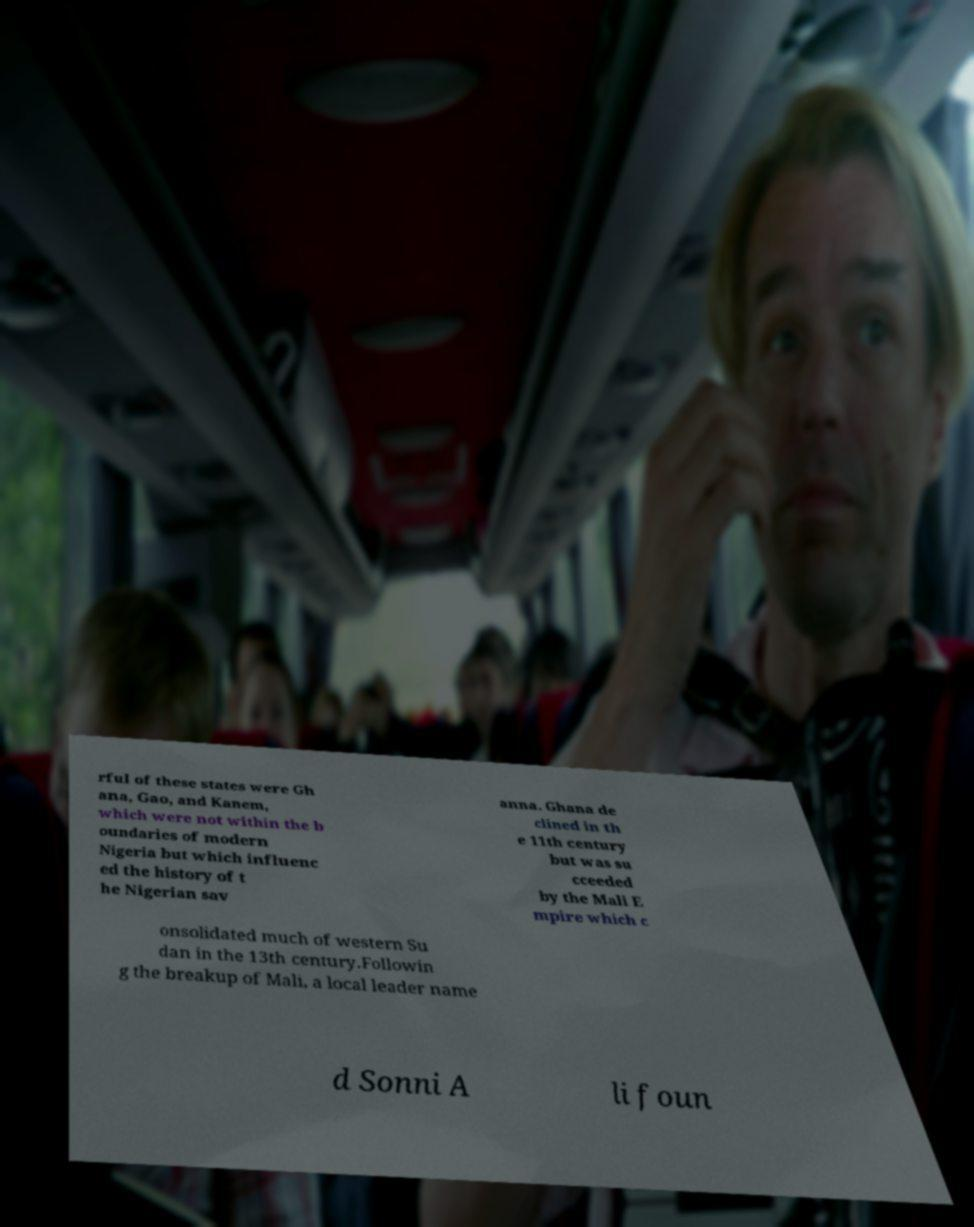For documentation purposes, I need the text within this image transcribed. Could you provide that? rful of these states were Gh ana, Gao, and Kanem, which were not within the b oundaries of modern Nigeria but which influenc ed the history of t he Nigerian sav anna. Ghana de clined in th e 11th century but was su cceeded by the Mali E mpire which c onsolidated much of western Su dan in the 13th century.Followin g the breakup of Mali, a local leader name d Sonni A li foun 